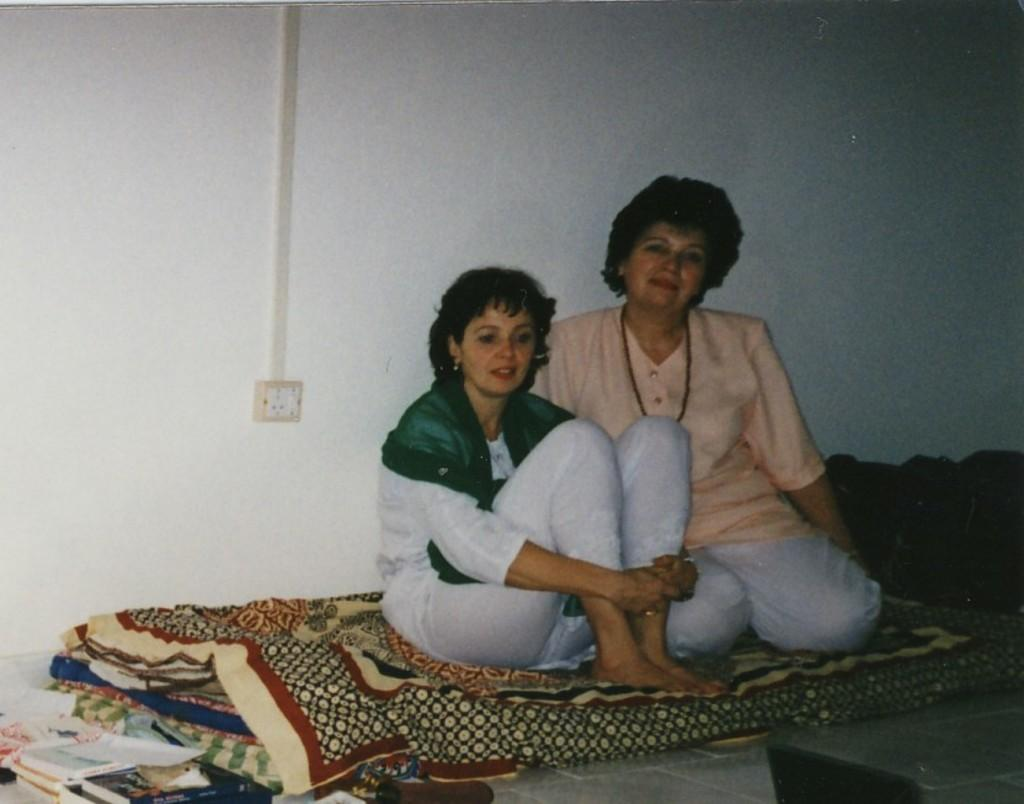What are the people in the image doing? The people in the image are sitting on the bed. What can be seen on a stand in the image? There are books on a stand in the image. What is located on the wall in the background of the image? There is a switch board on the wall in the background of the image. What type of fowl is sitting next to the judge in the image? There is no fowl or judge present in the image. What type of wine is being served to the people sitting on the bed in the image? There is no wine present in the image. 